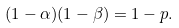<formula> <loc_0><loc_0><loc_500><loc_500>( 1 - \alpha ) ( 1 - \beta ) = 1 - p .</formula> 